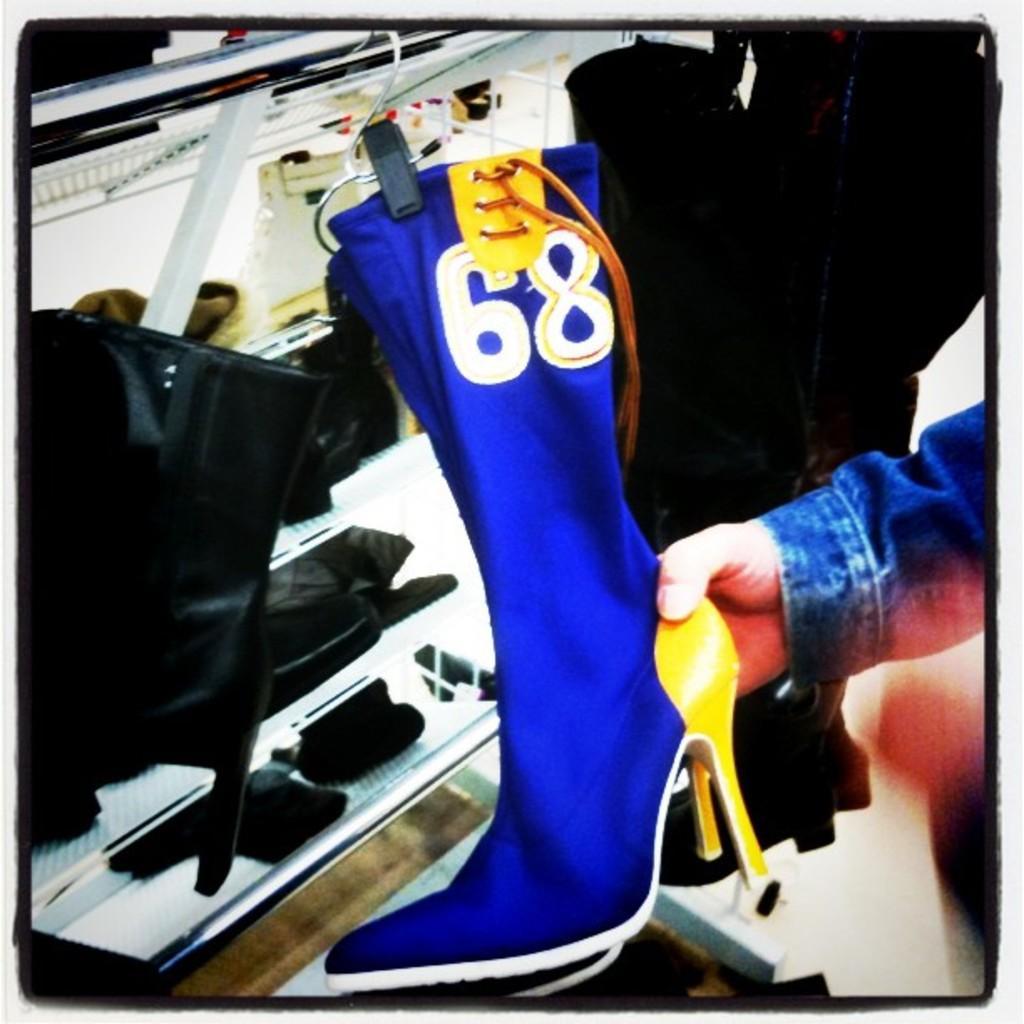In one or two sentences, can you explain what this image depicts? in this image I can see hand of a person is holding few blue colour shoes. On the top of this image I can see something is written. I can also see few black colour things in the background. 